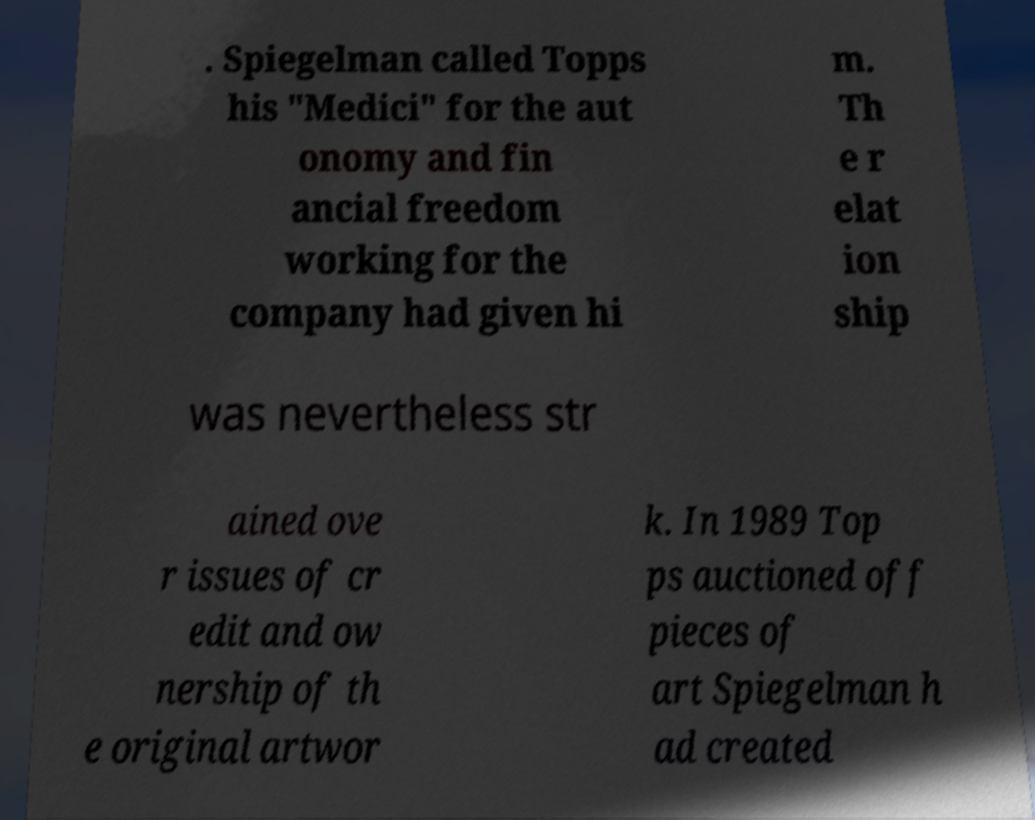There's text embedded in this image that I need extracted. Can you transcribe it verbatim? . Spiegelman called Topps his "Medici" for the aut onomy and fin ancial freedom working for the company had given hi m. Th e r elat ion ship was nevertheless str ained ove r issues of cr edit and ow nership of th e original artwor k. In 1989 Top ps auctioned off pieces of art Spiegelman h ad created 